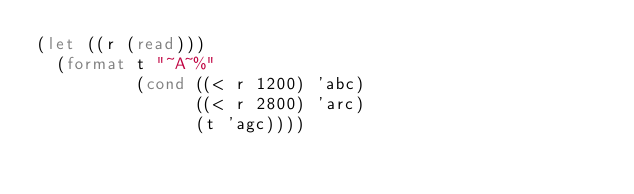<code> <loc_0><loc_0><loc_500><loc_500><_Lisp_>(let ((r (read)))
  (format t "~A~%"
          (cond ((< r 1200) 'abc)
                ((< r 2800) 'arc)
                (t 'agc))))
</code> 